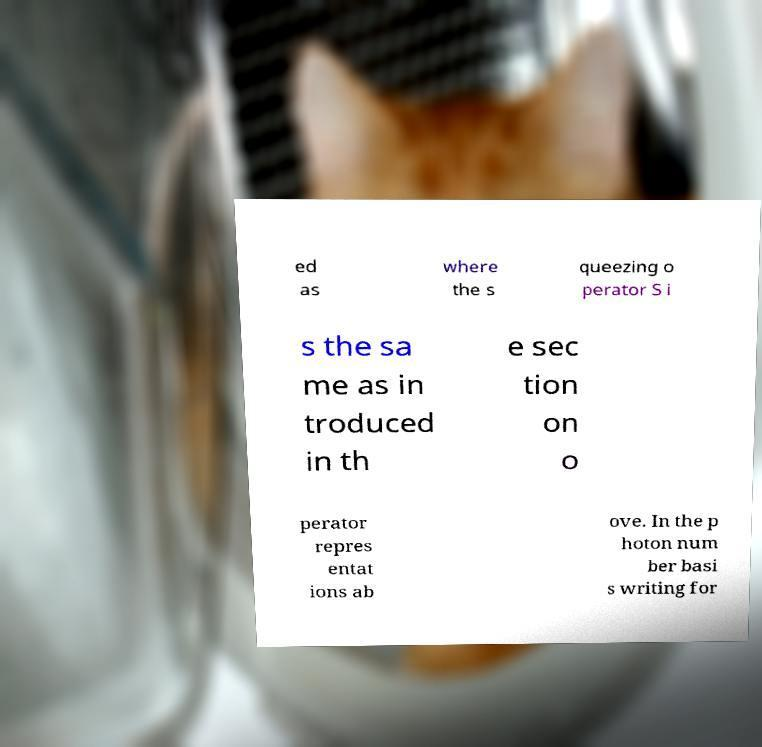Please read and relay the text visible in this image. What does it say? ed as where the s queezing o perator S i s the sa me as in troduced in th e sec tion on o perator repres entat ions ab ove. In the p hoton num ber basi s writing for 